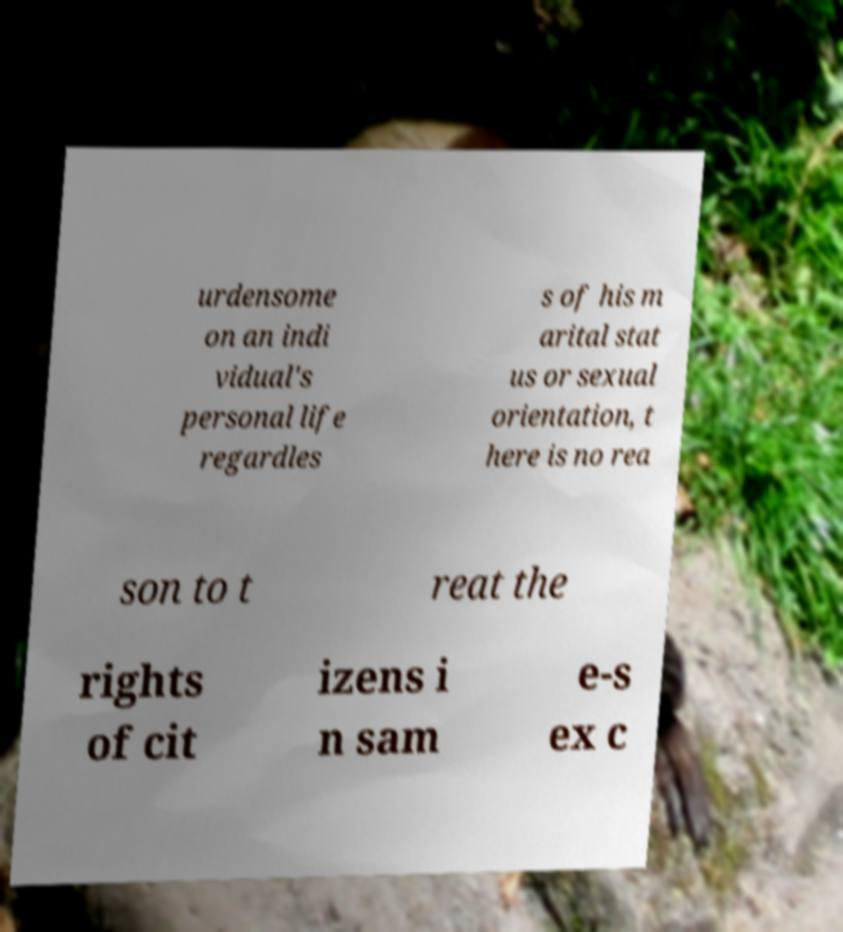For documentation purposes, I need the text within this image transcribed. Could you provide that? urdensome on an indi vidual's personal life regardles s of his m arital stat us or sexual orientation, t here is no rea son to t reat the rights of cit izens i n sam e-s ex c 